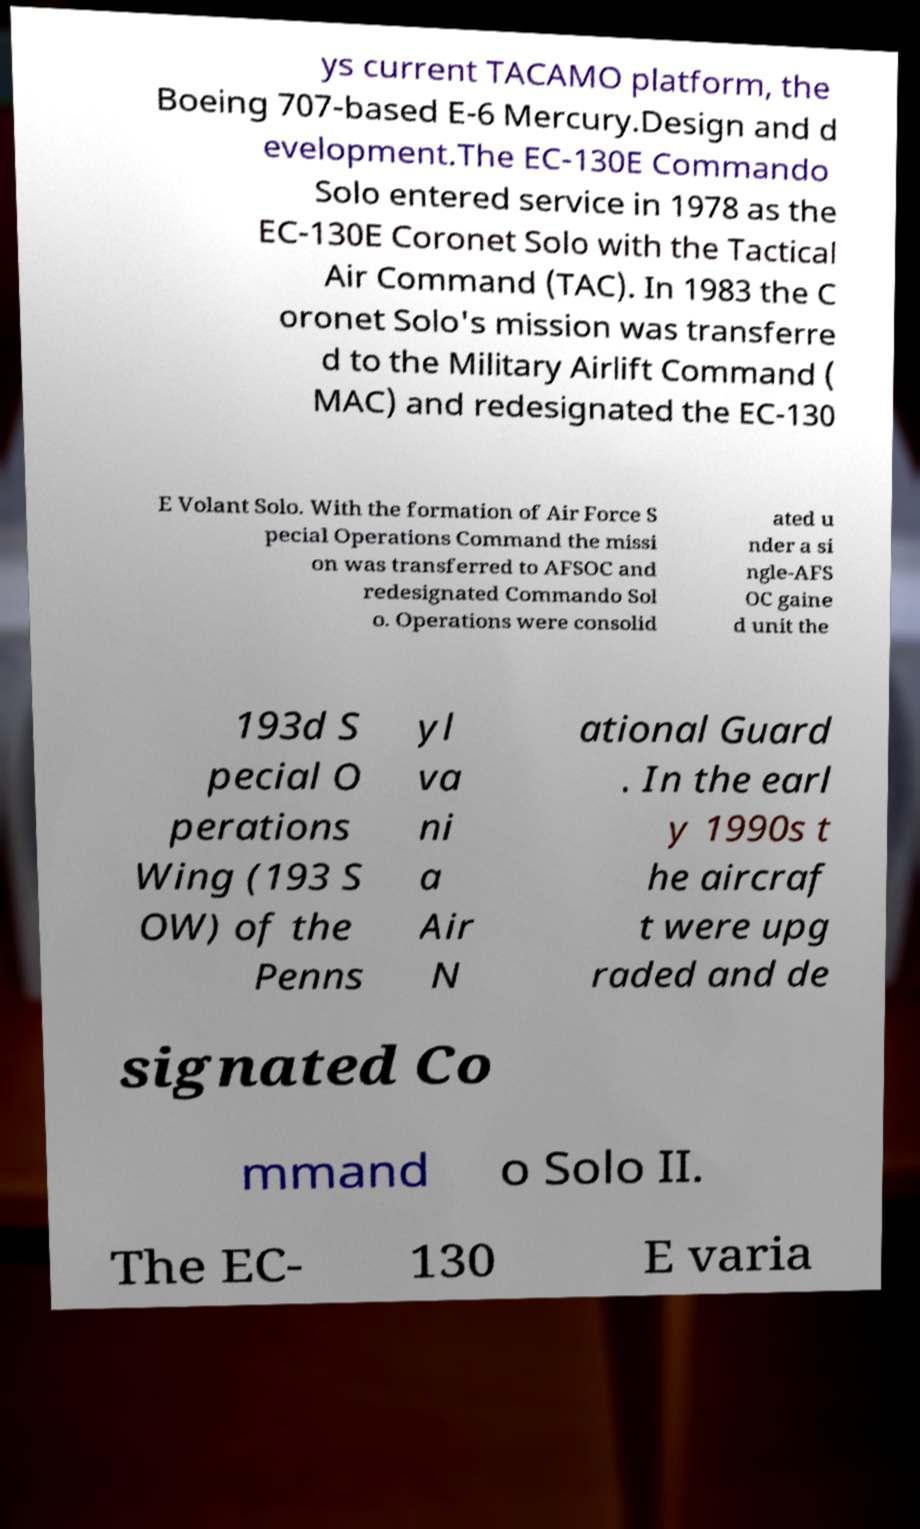Please read and relay the text visible in this image. What does it say? ys current TACAMO platform, the Boeing 707-based E-6 Mercury.Design and d evelopment.The EC-130E Commando Solo entered service in 1978 as the EC-130E Coronet Solo with the Tactical Air Command (TAC). In 1983 the C oronet Solo's mission was transferre d to the Military Airlift Command ( MAC) and redesignated the EC-130 E Volant Solo. With the formation of Air Force S pecial Operations Command the missi on was transferred to AFSOC and redesignated Commando Sol o. Operations were consolid ated u nder a si ngle-AFS OC gaine d unit the 193d S pecial O perations Wing (193 S OW) of the Penns yl va ni a Air N ational Guard . In the earl y 1990s t he aircraf t were upg raded and de signated Co mmand o Solo II. The EC- 130 E varia 